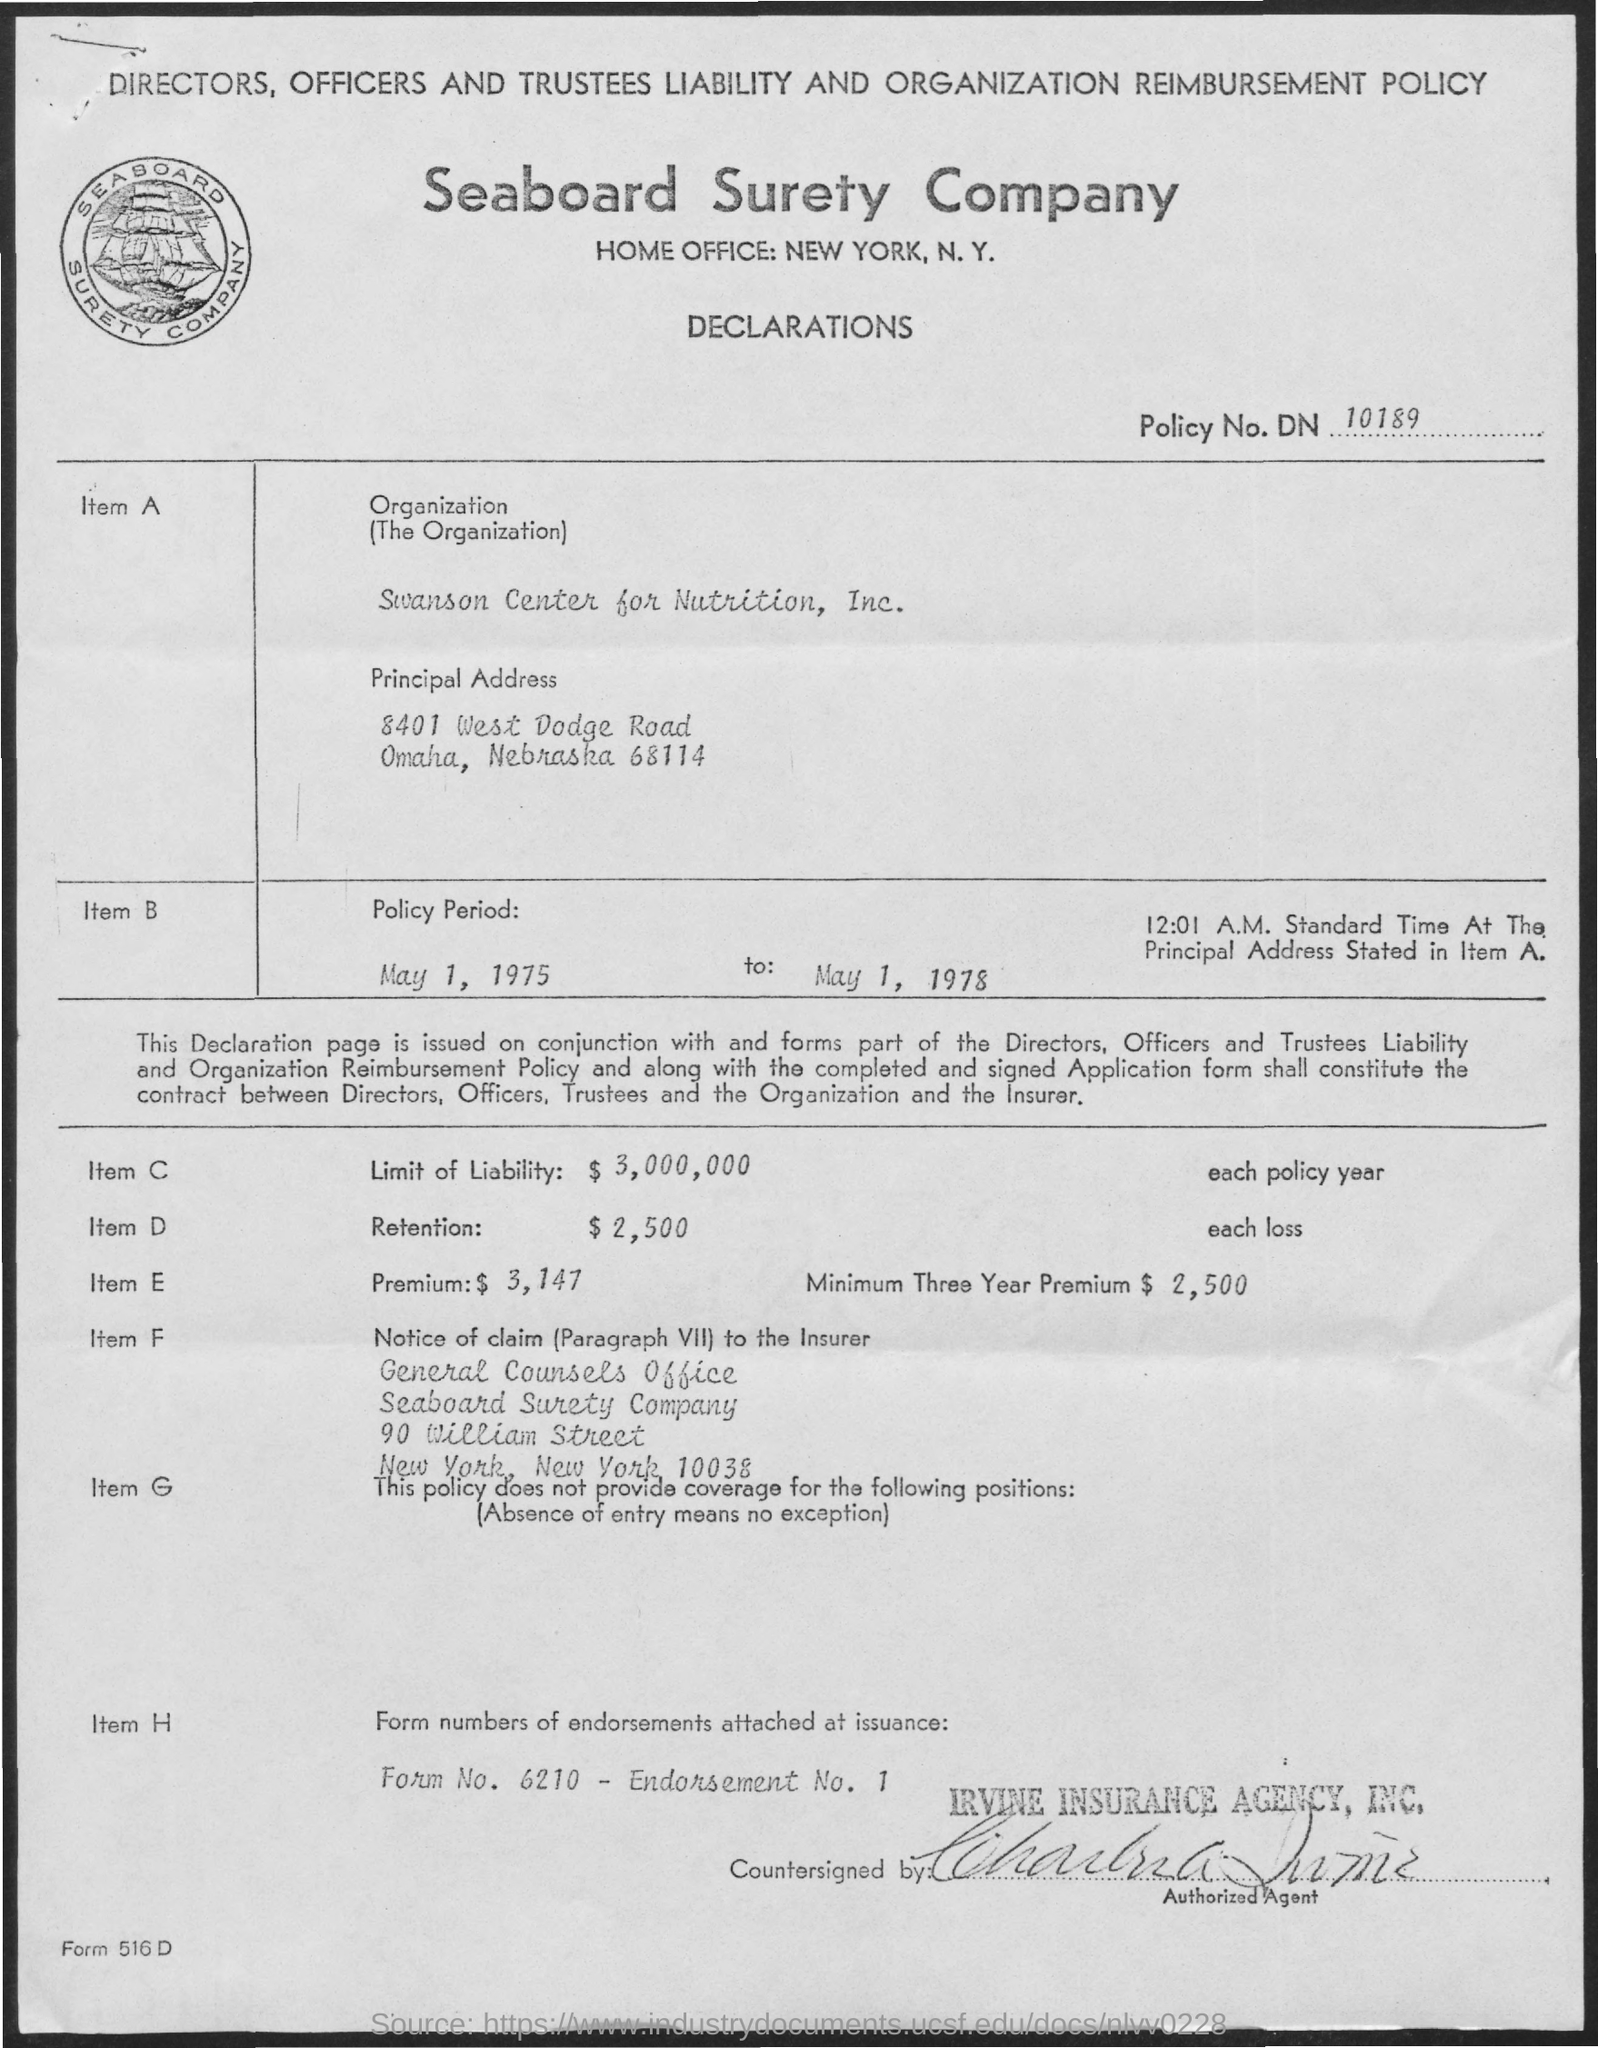Can you tell me about the type of insurance policy referenced in this document? The document references a 'Directors, Officers and Trustees Liability and Organization Reimbursement Policy.' It's designed to protect corporate leaders and the organization from financial losses due to legal actions taken against them in their official capacities.  What is the policy period for this insurance? The policy period spans from May 1, 1975, to May 1, 1978, as indicated in the 'Policy Period' section on the document. 